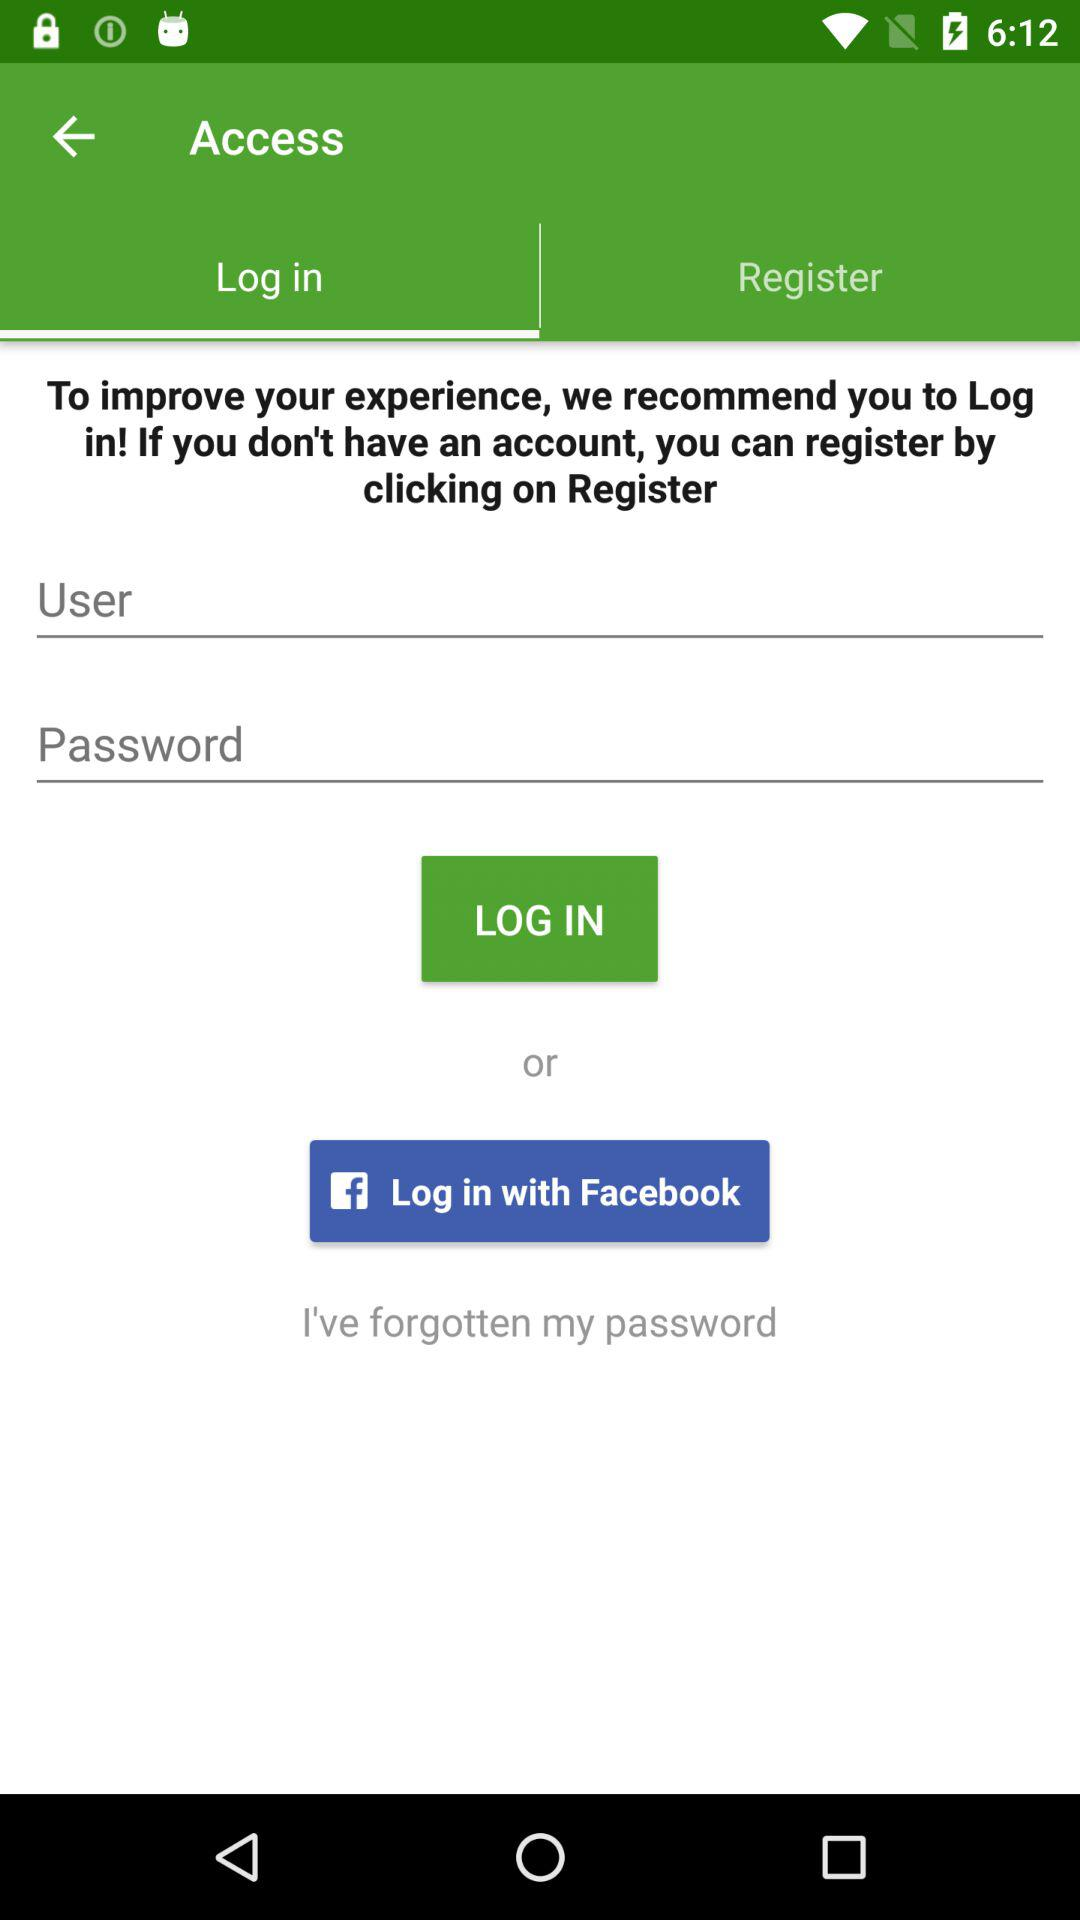What are the different login options? The different login option is "Facebook". 